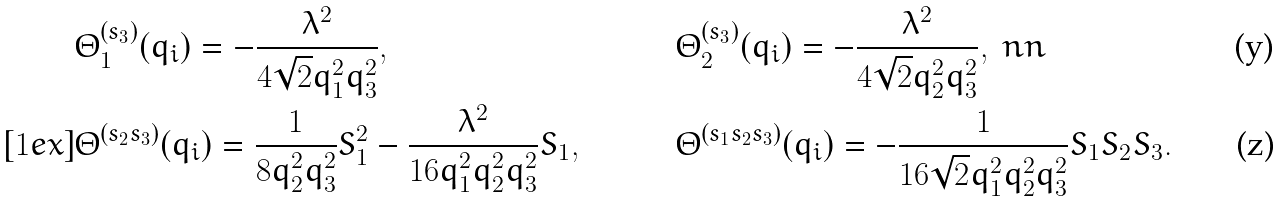<formula> <loc_0><loc_0><loc_500><loc_500>& \Theta _ { 1 } ^ { ( s _ { 3 } ) } ( q _ { i } ) = - \frac { \lambda ^ { 2 } } { 4 \sqrt { 2 } q _ { 1 } ^ { 2 } q _ { 3 } ^ { 2 } } , \quad & & \Theta _ { 2 } ^ { ( s _ { 3 } ) } ( q _ { i } ) = - \frac { \lambda ^ { 2 } } { 4 \sqrt { 2 } q _ { 2 } ^ { 2 } q _ { 3 } ^ { 2 } } , \ n n \\ [ 1 e x ] & \Theta ^ { ( s _ { 2 } s _ { 3 } ) } ( q _ { i } ) = \frac { 1 } { 8 q _ { 2 } ^ { 2 } q _ { 3 } ^ { 2 } } S _ { 1 } ^ { 2 } - \frac { \lambda ^ { 2 } } { 1 6 q _ { 1 } ^ { 2 } q _ { 2 } ^ { 2 } q _ { 3 } ^ { 2 } } S _ { 1 } , \quad & & \Theta ^ { ( s _ { 1 } s _ { 2 } s _ { 3 } ) } ( q _ { i } ) = - \frac { 1 } { 1 6 \sqrt { 2 } q _ { 1 } ^ { 2 } q _ { 2 } ^ { 2 } q _ { 3 } ^ { 2 } } S _ { 1 } S _ { 2 } S _ { 3 } .</formula> 